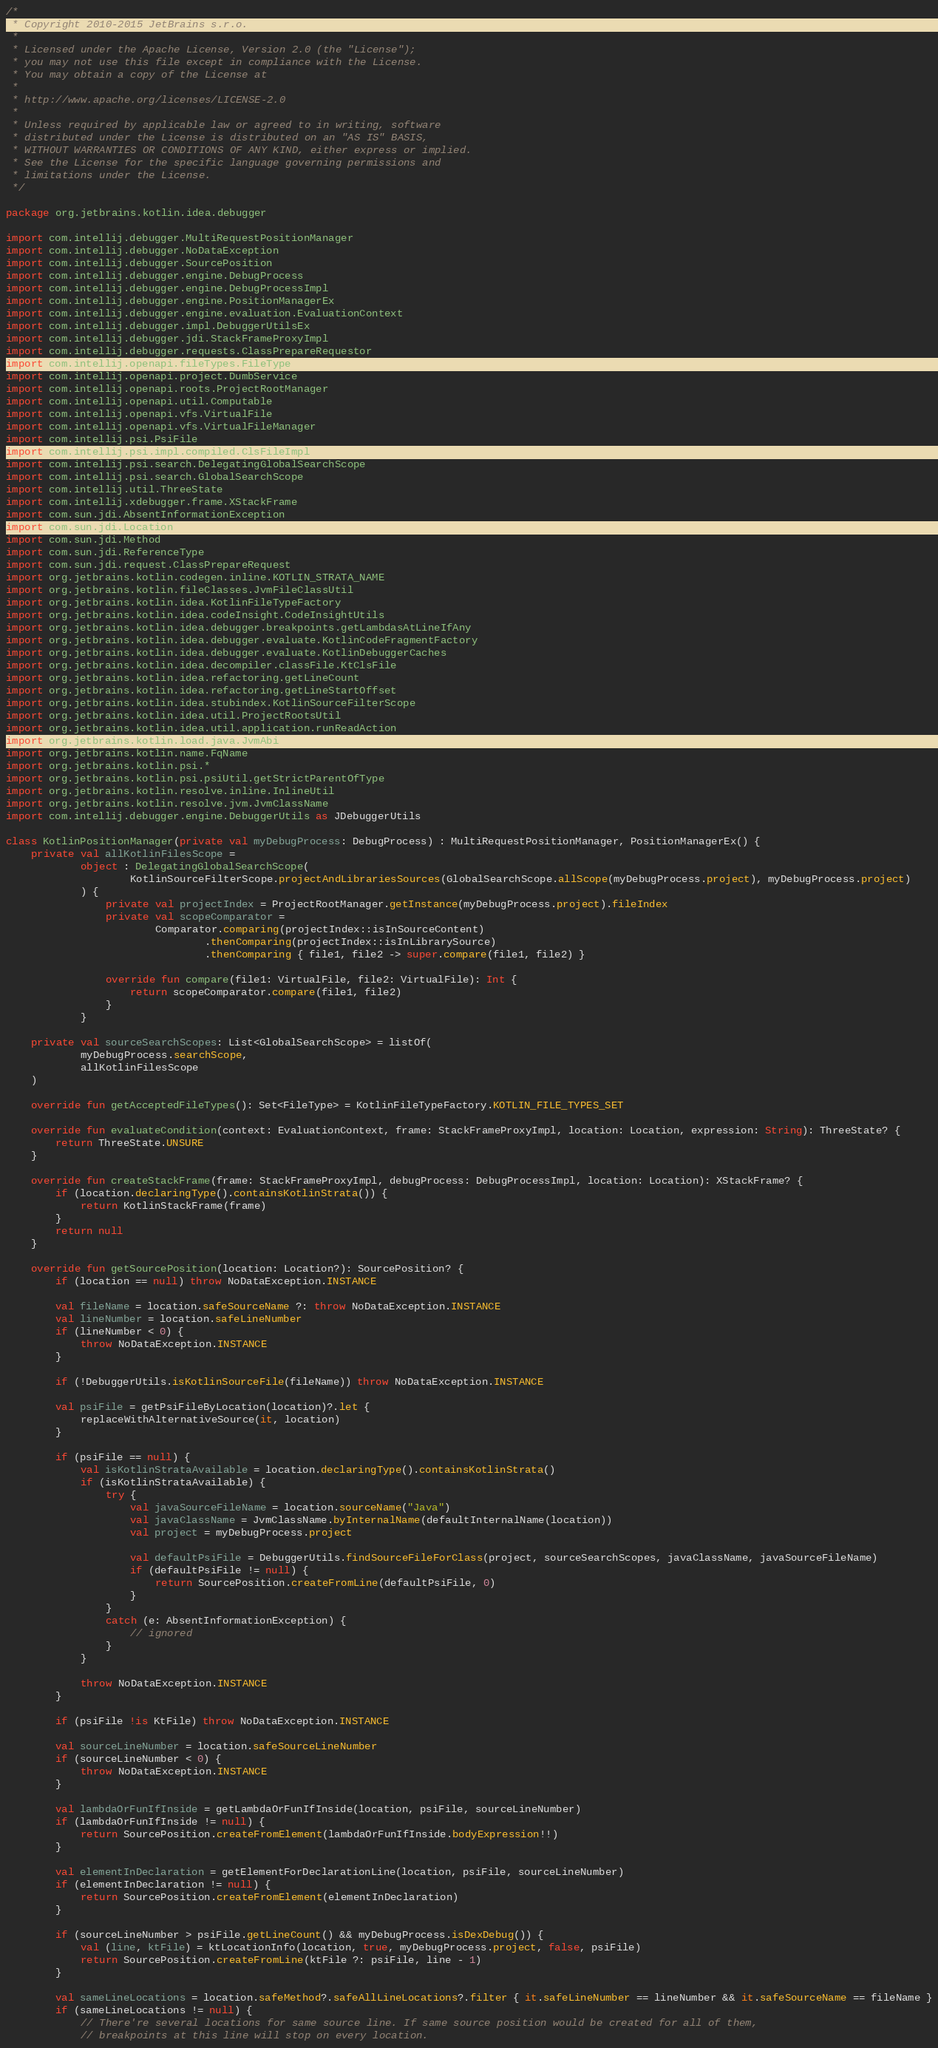Convert code to text. <code><loc_0><loc_0><loc_500><loc_500><_Kotlin_>/*
 * Copyright 2010-2015 JetBrains s.r.o.
 *
 * Licensed under the Apache License, Version 2.0 (the "License");
 * you may not use this file except in compliance with the License.
 * You may obtain a copy of the License at
 *
 * http://www.apache.org/licenses/LICENSE-2.0
 *
 * Unless required by applicable law or agreed to in writing, software
 * distributed under the License is distributed on an "AS IS" BASIS,
 * WITHOUT WARRANTIES OR CONDITIONS OF ANY KIND, either express or implied.
 * See the License for the specific language governing permissions and
 * limitations under the License.
 */

package org.jetbrains.kotlin.idea.debugger

import com.intellij.debugger.MultiRequestPositionManager
import com.intellij.debugger.NoDataException
import com.intellij.debugger.SourcePosition
import com.intellij.debugger.engine.DebugProcess
import com.intellij.debugger.engine.DebugProcessImpl
import com.intellij.debugger.engine.PositionManagerEx
import com.intellij.debugger.engine.evaluation.EvaluationContext
import com.intellij.debugger.impl.DebuggerUtilsEx
import com.intellij.debugger.jdi.StackFrameProxyImpl
import com.intellij.debugger.requests.ClassPrepareRequestor
import com.intellij.openapi.fileTypes.FileType
import com.intellij.openapi.project.DumbService
import com.intellij.openapi.roots.ProjectRootManager
import com.intellij.openapi.util.Computable
import com.intellij.openapi.vfs.VirtualFile
import com.intellij.openapi.vfs.VirtualFileManager
import com.intellij.psi.PsiFile
import com.intellij.psi.impl.compiled.ClsFileImpl
import com.intellij.psi.search.DelegatingGlobalSearchScope
import com.intellij.psi.search.GlobalSearchScope
import com.intellij.util.ThreeState
import com.intellij.xdebugger.frame.XStackFrame
import com.sun.jdi.AbsentInformationException
import com.sun.jdi.Location
import com.sun.jdi.Method
import com.sun.jdi.ReferenceType
import com.sun.jdi.request.ClassPrepareRequest
import org.jetbrains.kotlin.codegen.inline.KOTLIN_STRATA_NAME
import org.jetbrains.kotlin.fileClasses.JvmFileClassUtil
import org.jetbrains.kotlin.idea.KotlinFileTypeFactory
import org.jetbrains.kotlin.idea.codeInsight.CodeInsightUtils
import org.jetbrains.kotlin.idea.debugger.breakpoints.getLambdasAtLineIfAny
import org.jetbrains.kotlin.idea.debugger.evaluate.KotlinCodeFragmentFactory
import org.jetbrains.kotlin.idea.debugger.evaluate.KotlinDebuggerCaches
import org.jetbrains.kotlin.idea.decompiler.classFile.KtClsFile
import org.jetbrains.kotlin.idea.refactoring.getLineCount
import org.jetbrains.kotlin.idea.refactoring.getLineStartOffset
import org.jetbrains.kotlin.idea.stubindex.KotlinSourceFilterScope
import org.jetbrains.kotlin.idea.util.ProjectRootsUtil
import org.jetbrains.kotlin.idea.util.application.runReadAction
import org.jetbrains.kotlin.load.java.JvmAbi
import org.jetbrains.kotlin.name.FqName
import org.jetbrains.kotlin.psi.*
import org.jetbrains.kotlin.psi.psiUtil.getStrictParentOfType
import org.jetbrains.kotlin.resolve.inline.InlineUtil
import org.jetbrains.kotlin.resolve.jvm.JvmClassName
import com.intellij.debugger.engine.DebuggerUtils as JDebuggerUtils

class KotlinPositionManager(private val myDebugProcess: DebugProcess) : MultiRequestPositionManager, PositionManagerEx() {
    private val allKotlinFilesScope =
            object : DelegatingGlobalSearchScope(
                    KotlinSourceFilterScope.projectAndLibrariesSources(GlobalSearchScope.allScope(myDebugProcess.project), myDebugProcess.project)
            ) {
                private val projectIndex = ProjectRootManager.getInstance(myDebugProcess.project).fileIndex
                private val scopeComparator =
                        Comparator.comparing(projectIndex::isInSourceContent)
                                .thenComparing(projectIndex::isInLibrarySource)
                                .thenComparing { file1, file2 -> super.compare(file1, file2) }

                override fun compare(file1: VirtualFile, file2: VirtualFile): Int {
                    return scopeComparator.compare(file1, file2)
                }
            }

    private val sourceSearchScopes: List<GlobalSearchScope> = listOf(
            myDebugProcess.searchScope,
            allKotlinFilesScope
    )

    override fun getAcceptedFileTypes(): Set<FileType> = KotlinFileTypeFactory.KOTLIN_FILE_TYPES_SET

    override fun evaluateCondition(context: EvaluationContext, frame: StackFrameProxyImpl, location: Location, expression: String): ThreeState? {
        return ThreeState.UNSURE
    }

    override fun createStackFrame(frame: StackFrameProxyImpl, debugProcess: DebugProcessImpl, location: Location): XStackFrame? {
        if (location.declaringType().containsKotlinStrata()) {
            return KotlinStackFrame(frame)
        }
        return null
    }

    override fun getSourcePosition(location: Location?): SourcePosition? {
        if (location == null) throw NoDataException.INSTANCE

        val fileName = location.safeSourceName ?: throw NoDataException.INSTANCE
        val lineNumber = location.safeLineNumber
        if (lineNumber < 0) {
            throw NoDataException.INSTANCE
        }

        if (!DebuggerUtils.isKotlinSourceFile(fileName)) throw NoDataException.INSTANCE

        val psiFile = getPsiFileByLocation(location)?.let {
            replaceWithAlternativeSource(it, location)
        }

        if (psiFile == null) {
            val isKotlinStrataAvailable = location.declaringType().containsKotlinStrata()
            if (isKotlinStrataAvailable) {
                try {
                    val javaSourceFileName = location.sourceName("Java")
                    val javaClassName = JvmClassName.byInternalName(defaultInternalName(location))
                    val project = myDebugProcess.project

                    val defaultPsiFile = DebuggerUtils.findSourceFileForClass(project, sourceSearchScopes, javaClassName, javaSourceFileName)
                    if (defaultPsiFile != null) {
                        return SourcePosition.createFromLine(defaultPsiFile, 0)
                    }
                }
                catch (e: AbsentInformationException) {
                    // ignored
                }
            }

            throw NoDataException.INSTANCE
        }

        if (psiFile !is KtFile) throw NoDataException.INSTANCE

        val sourceLineNumber = location.safeSourceLineNumber
        if (sourceLineNumber < 0) {
            throw NoDataException.INSTANCE
        }

        val lambdaOrFunIfInside = getLambdaOrFunIfInside(location, psiFile, sourceLineNumber)
        if (lambdaOrFunIfInside != null) {
            return SourcePosition.createFromElement(lambdaOrFunIfInside.bodyExpression!!)
        }

        val elementInDeclaration = getElementForDeclarationLine(location, psiFile, sourceLineNumber)
        if (elementInDeclaration != null) {
            return SourcePosition.createFromElement(elementInDeclaration)
        }

        if (sourceLineNumber > psiFile.getLineCount() && myDebugProcess.isDexDebug()) {
            val (line, ktFile) = ktLocationInfo(location, true, myDebugProcess.project, false, psiFile)
            return SourcePosition.createFromLine(ktFile ?: psiFile, line - 1)
        }

        val sameLineLocations = location.safeMethod?.safeAllLineLocations?.filter { it.safeLineNumber == lineNumber && it.safeSourceName == fileName }
        if (sameLineLocations != null) {
            // There're several locations for same source line. If same source position would be created for all of them,
            // breakpoints at this line will stop on every location.</code> 